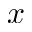<formula> <loc_0><loc_0><loc_500><loc_500>x</formula> 